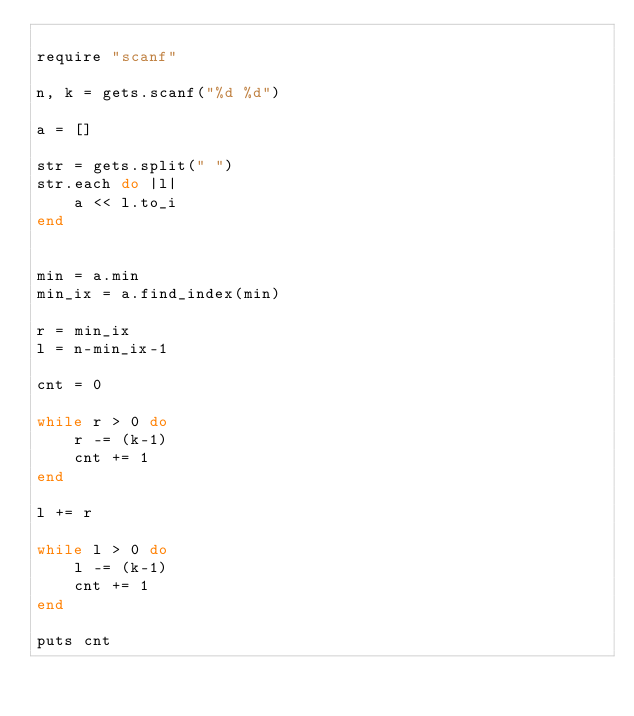Convert code to text. <code><loc_0><loc_0><loc_500><loc_500><_Ruby_>
require "scanf"

n, k = gets.scanf("%d %d")

a = []

str = gets.split(" ")
str.each do |l|
    a << l.to_i
end


min = a.min
min_ix = a.find_index(min)

r = min_ix
l = n-min_ix-1

cnt = 0

while r > 0 do
    r -= (k-1)
    cnt += 1
end

l += r

while l > 0 do
    l -= (k-1)
    cnt += 1
end

puts cnt
</code> 